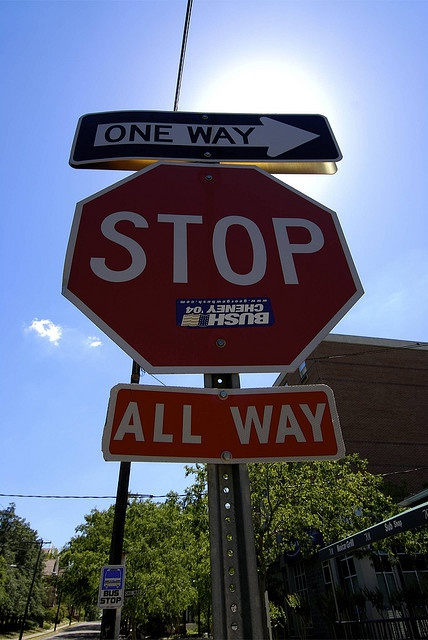Describe the objects in this image and their specific colors. I can see a stop sign in lightblue, black, and gray tones in this image. 